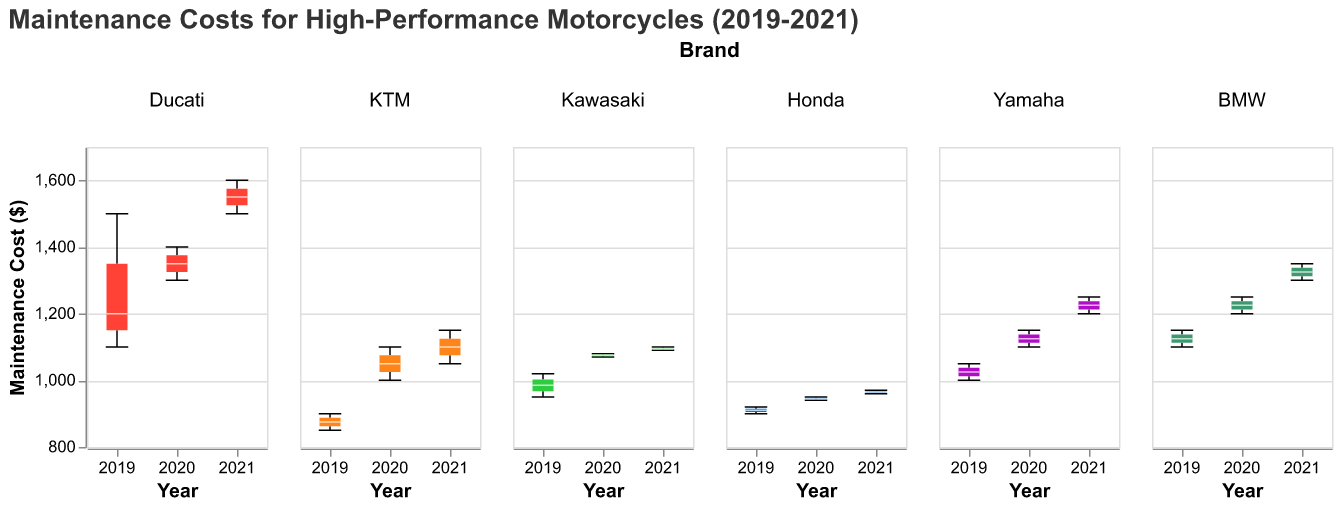what is the title of the figure? The title appears at the top of the figure.
Answer: Maintenance Costs for High-Performance Motorcycles (2019-2021) Which motorcycle brand has the highest median maintenance cost across all years? Look at the boxplots for each brand and compare their median lines. Ducati has the highest median value.
Answer: Ducati For which year does the Ducati Panigale V4 have the highest maintenance cost? Examine the 2019, 2020, and 2021 box plots for Ducati Panigale V4. The highest median maintenance cost is in 2021.
Answer: 2021 Which brand has the lowest maintenance cost in 2019? Compare the minimum values in the 2019 box plots for all brands. KTM has the lowest maintenance cost in 2019.
Answer: KTM What is the range of maintenance costs for BMW S1000RR in 2020? Look at the box plot for BMW in 2020 and note the minimum and maximum values. The range is 1200 to 1250.
Answer: 1200 to 1250 Which brand shows the most consistency in maintenance costs over the years? Consistency can be identified by the smallest range and fewer outliers in the box plots across 2019, 2020, and 2021. Honda shows the most consistency.
Answer: Honda How does the median maintenance cost of the Yamaha YZF-R1 in 2021 compare to its median cost in 2019? Compare the median lines for the Yamaha YZF-R1 box plots in 2019 and 2021. The median maintenance cost in 2021 is higher.
Answer: Higher in 2021 What is the difference between the maximum and minimum maintenance costs for the Kawasaki Ninja ZX-10R in 2020? Identify the maximum and minimum values in the 2020 box plot for Kawasaki. The difference is 1080 - 1070 = 10.
Answer: 10 Which motorcycle brand has shown the highest increase in maintenance costs from 2019 to 2021? Compare the changes in median maintenance costs for each brand from 2019 to 2021. Ducati shows the highest increase.
Answer: Ducati What is the interquartile range (IQR) for the Honda CBR1000RR in 2021? The IQR is the difference between the first quartile (Q1) and third quartile (Q3) values in the 2021 box plot for Honda. The IQR is 970 - 960 = 10.
Answer: 10 